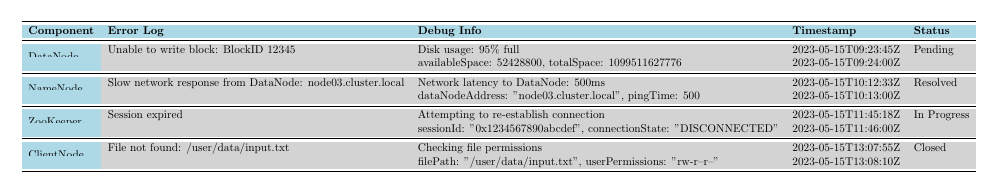What is the error message associated with log ID 1001? In the table, under the "Error Log" column for log ID 1001, the error message is "Unable to write block: BlockID 12345."
Answer: Unable to write block: BlockID 12345 Which component has a resolution status of "Resolved"? Looking at the "Status" column in the table, the NameNode component has a resolution status of "Resolved."
Answer: NameNode What is the timestamp for the critical error logged for ZooKeeper? In the table, the timestamp corresponding to the critical error for ZooKeeper is "2023-05-15T11:45:18Z."
Answer: 2023-05-15T11:45:18Z Is there a debug message recorded for the ClientNode component? Yes, there is a debug message for the ClientNode component as shown in the "Debug Info" column, which states "Checking file permissions."
Answer: Yes What percentage of disk usage was reported in the debug message for DataNode? The debug message for DataNode reported "Disk usage: 95% full," indicating the percentage of disk usage.
Answer: 95% How many total error log entries are there for the system? By counting the entries listed in the "Error Log" section of the table, there are a total of four error log entries.
Answer: 4 Which component has a session error, and what is the resolution status? The ZooKeeper component has a session error, and its resolution status is "In Progress" as listed in the respective columns.
Answer: ZooKeeper, In Progress What is the available space reported in the debug information for DataNode? According to the "Debug Info" column for DataNode, the available space reported is 52,428,800 bytes.
Answer: 52,428,800 bytes What are the components that have errors logged? The components with errors logged are DataNode, NameNode, ZooKeeper, and ClientNode, as shown in the "Component" column.
Answer: DataNode, NameNode, ZooKeeper, ClientNode Which error log has the most severe severity level and what is its corresponding error message? The error log with the most severe severity level is for ZooKeeper, labeled as "CRITICAL," and the corresponding error message is "Session expired."
Answer: Session expired 